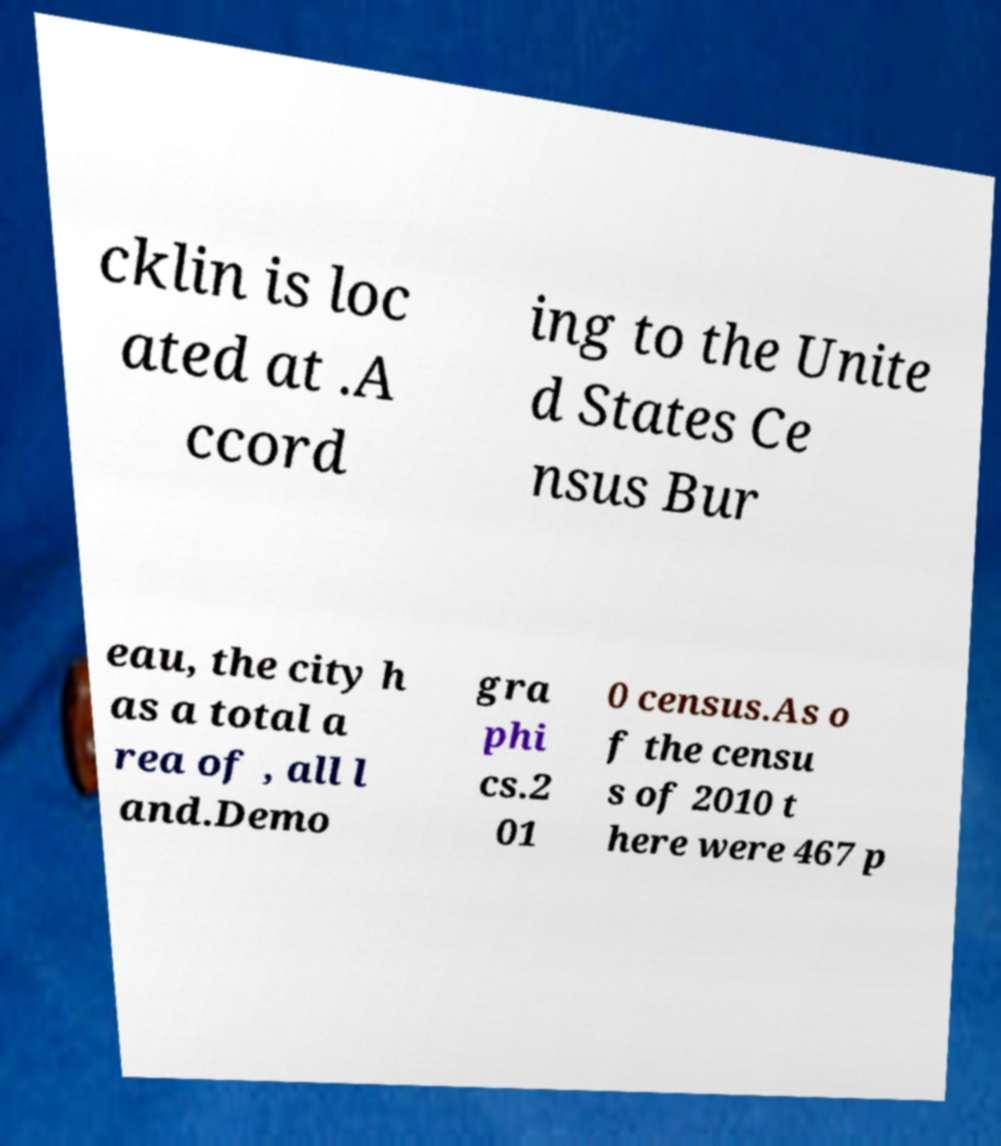What messages or text are displayed in this image? I need them in a readable, typed format. cklin is loc ated at .A ccord ing to the Unite d States Ce nsus Bur eau, the city h as a total a rea of , all l and.Demo gra phi cs.2 01 0 census.As o f the censu s of 2010 t here were 467 p 